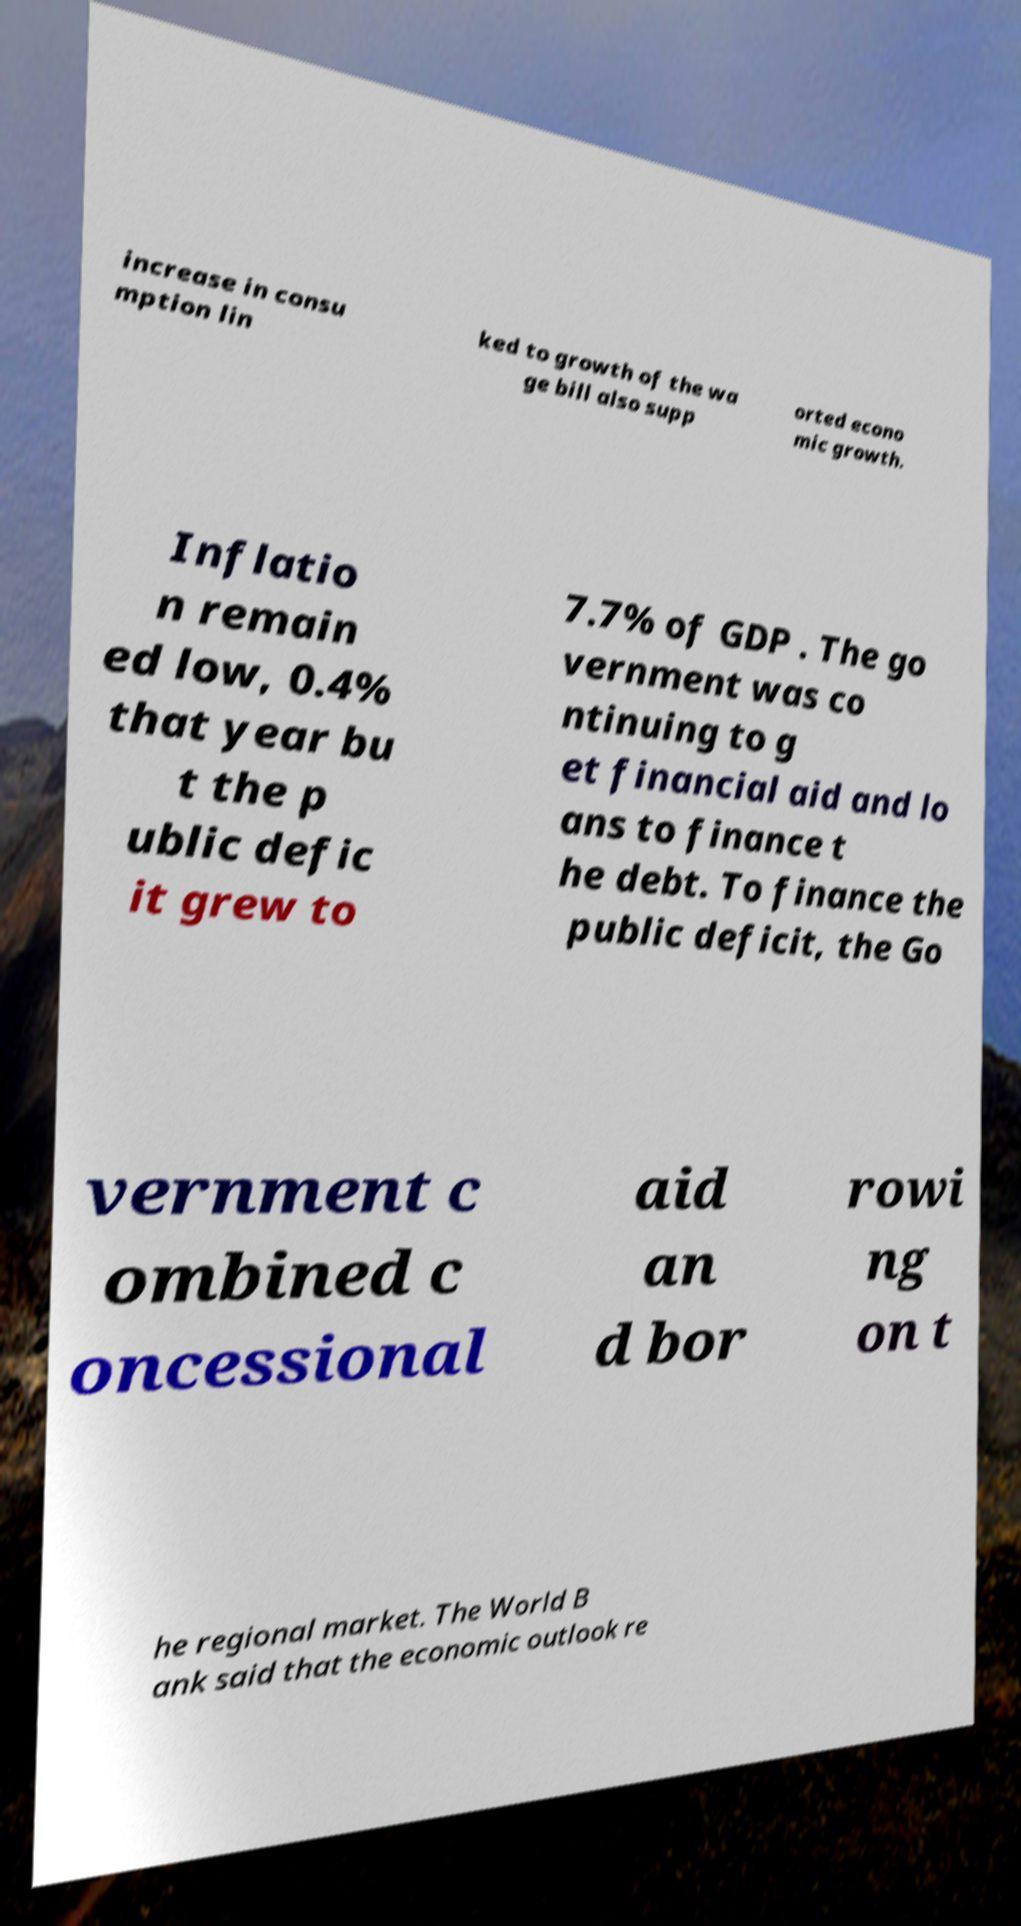There's text embedded in this image that I need extracted. Can you transcribe it verbatim? increase in consu mption lin ked to growth of the wa ge bill also supp orted econo mic growth. Inflatio n remain ed low, 0.4% that year bu t the p ublic defic it grew to 7.7% of GDP . The go vernment was co ntinuing to g et financial aid and lo ans to finance t he debt. To finance the public deficit, the Go vernment c ombined c oncessional aid an d bor rowi ng on t he regional market. The World B ank said that the economic outlook re 